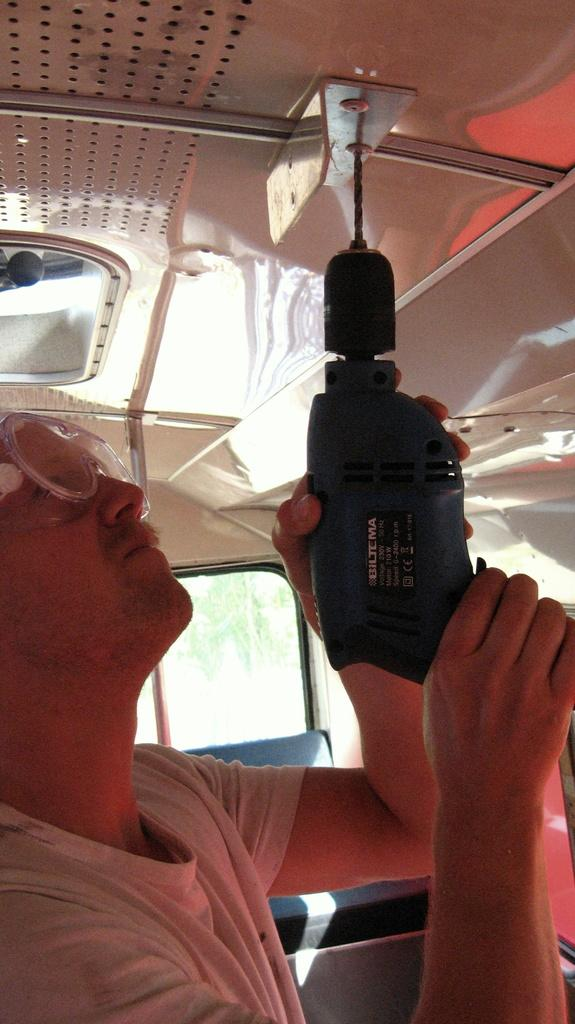What is the main subject of the picture? The main subject of the picture is a man. What is the man doing in the picture? The man is standing in the picture. What object is the man holding in the picture? The man is holding a drilling machine in the picture. What type of grain is being processed by the man in the picture? There is no grain present in the image, and the man is not processing any grain. 